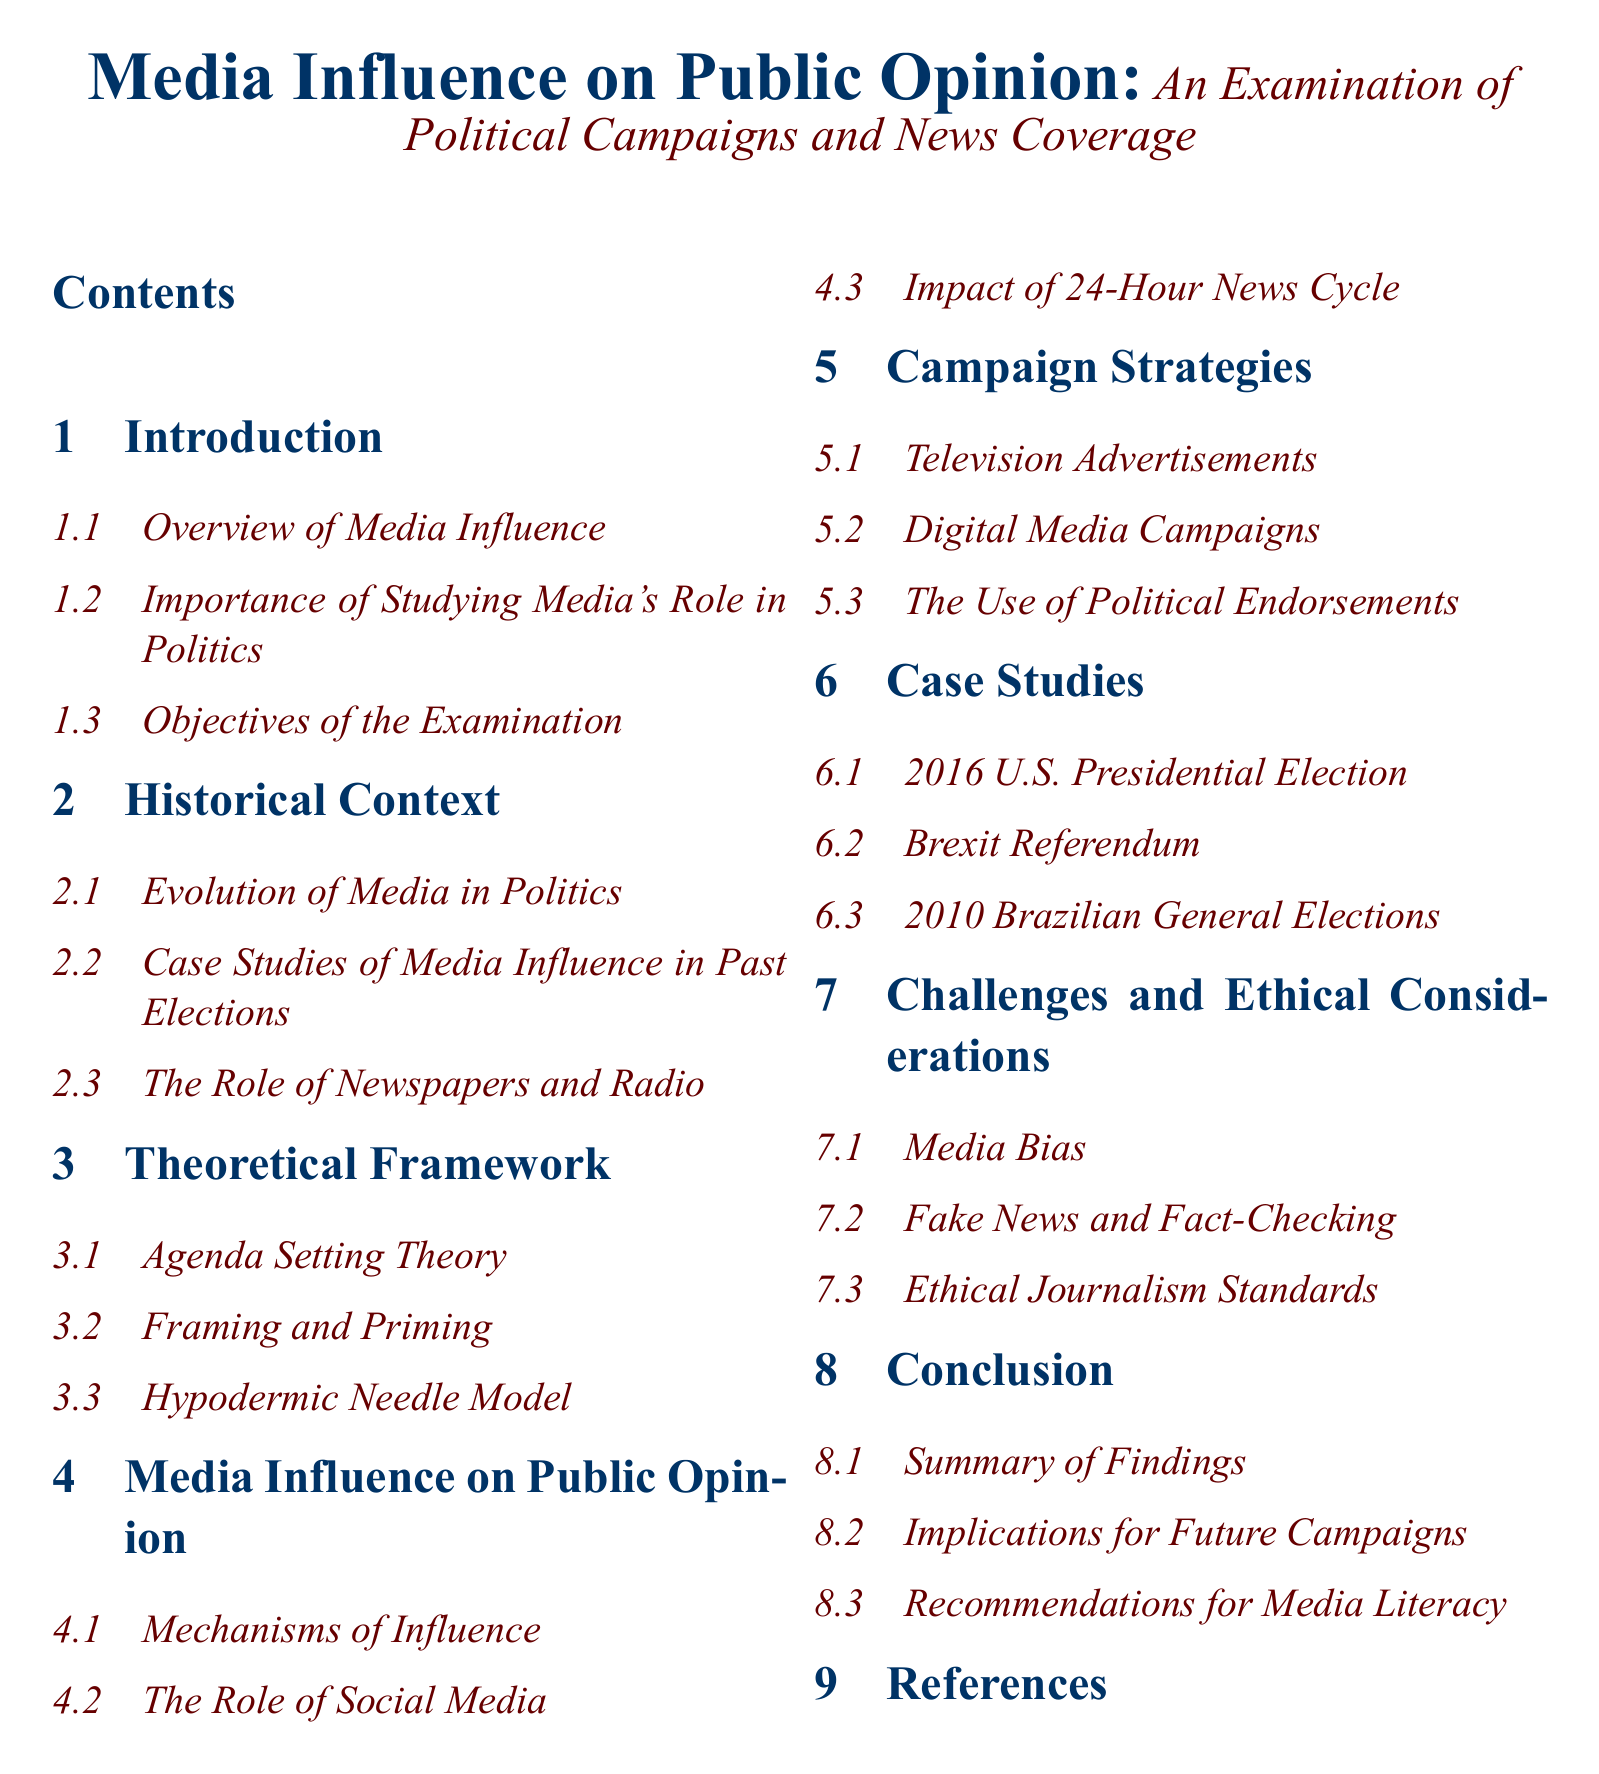What is the title of the document? The title is stated at the beginning of the document, presenting the main theme.
Answer: Media Influence on Public Opinion: An Examination of Political Campaigns and News Coverage How many sections are there in the table of contents? The total number of sections can be counted from the table of contents entries listed.
Answer: 8 Which case study is included related to the 2016 U.S. Presidential Election? The specific section addresses this case as one of the detailed studies in the document.
Answer: 2016 U.S. Presidential Election What is the main theoretical framework discussed? This refers to the section that outlines the theories related to media influence in politics.
Answer: Agenda Setting Theory What are the three types of media influence mechanisms mentioned? The section provides an outline of the different mechanisms under discussion.
Answer: Mechanisms of Influence Which ethical consideration is highlighted in the document? The specific subsection discusses moral implications of media reporting.
Answer: Media Bias What is one of the recommendations for future campaigns? This refers to suggestions mentioned in the conclusion based on the findings throughout the document.
Answer: Recommendations for Media Literacy What type of media campaign is discussed in the context of campaign strategies? This section covers various strategies employed in political campaigns.
Answer: Digital Media Campaigns 